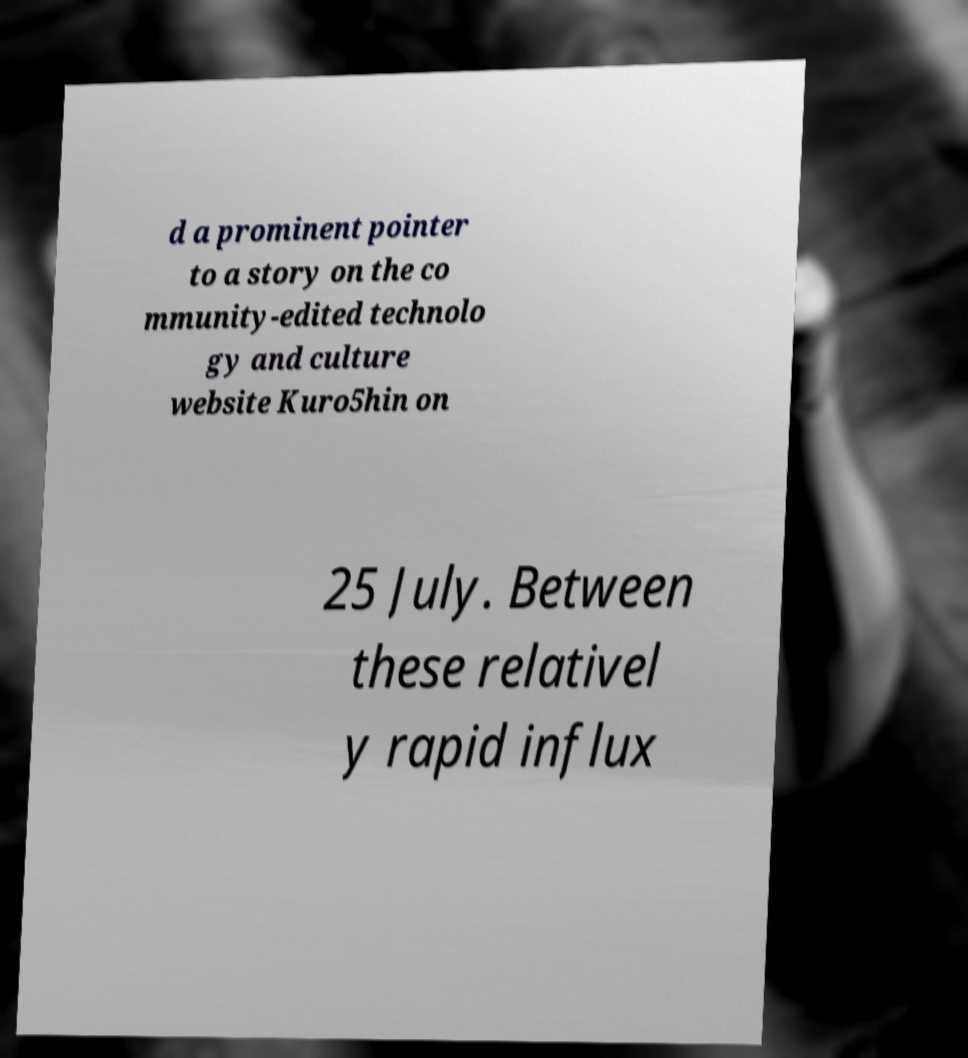Can you read and provide the text displayed in the image?This photo seems to have some interesting text. Can you extract and type it out for me? d a prominent pointer to a story on the co mmunity-edited technolo gy and culture website Kuro5hin on 25 July. Between these relativel y rapid influx 